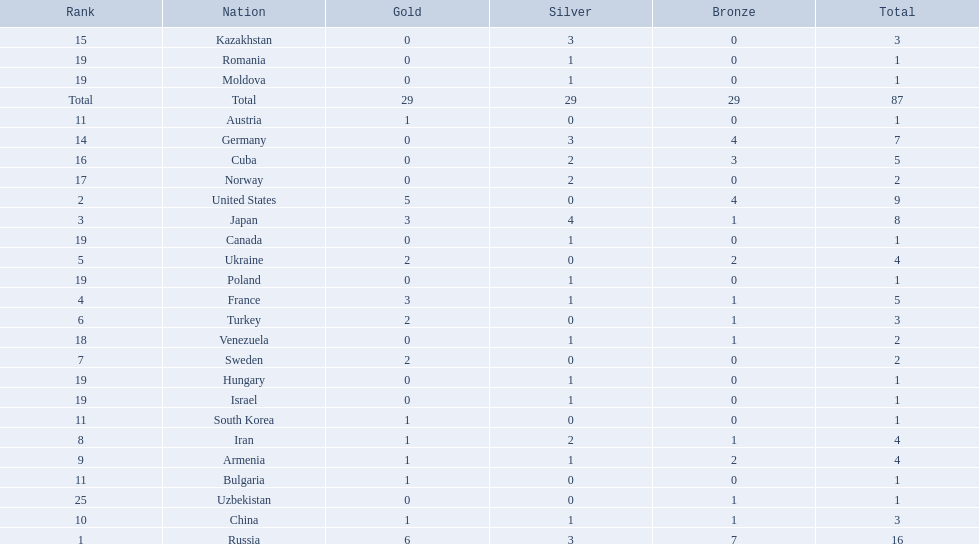Which countries competed in the 1995 world wrestling championships? Russia, United States, Japan, France, Ukraine, Turkey, Sweden, Iran, Armenia, China, Austria, Bulgaria, South Korea, Germany, Kazakhstan, Cuba, Norway, Venezuela, Canada, Hungary, Israel, Moldova, Poland, Romania, Uzbekistan. What country won only one medal? Austria, Bulgaria, South Korea, Canada, Hungary, Israel, Moldova, Poland, Romania, Uzbekistan. Which of these won a bronze medal? Uzbekistan. 